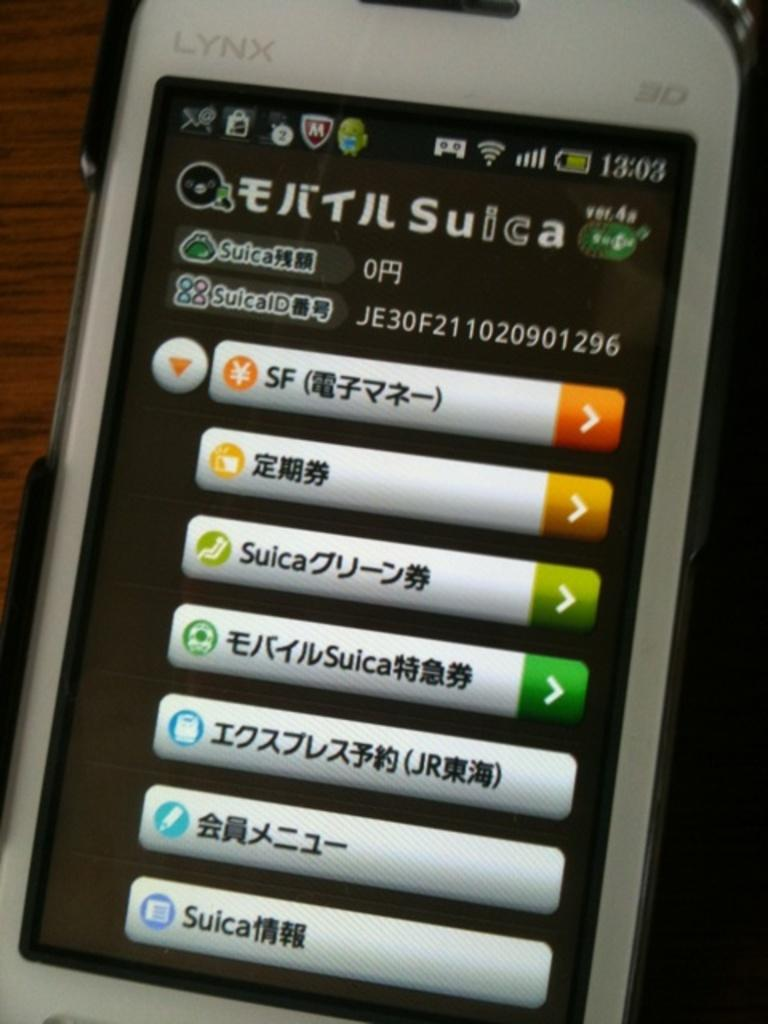Provide a one-sentence caption for the provided image. A Lynx phone displays that the time is 13:03. 